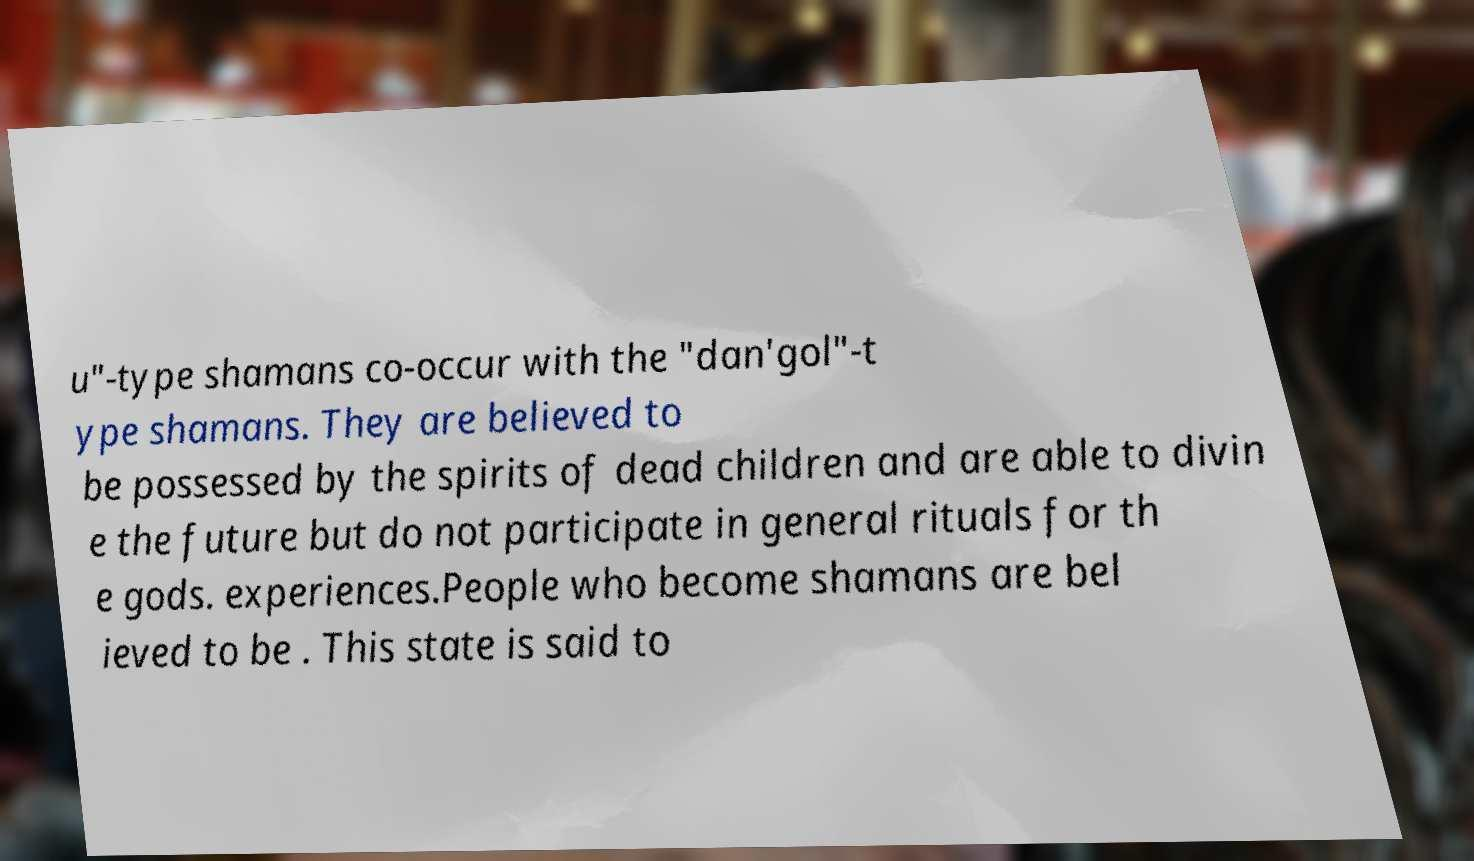There's text embedded in this image that I need extracted. Can you transcribe it verbatim? u"-type shamans co-occur with the "dan'gol"-t ype shamans. They are believed to be possessed by the spirits of dead children and are able to divin e the future but do not participate in general rituals for th e gods. experiences.People who become shamans are bel ieved to be . This state is said to 